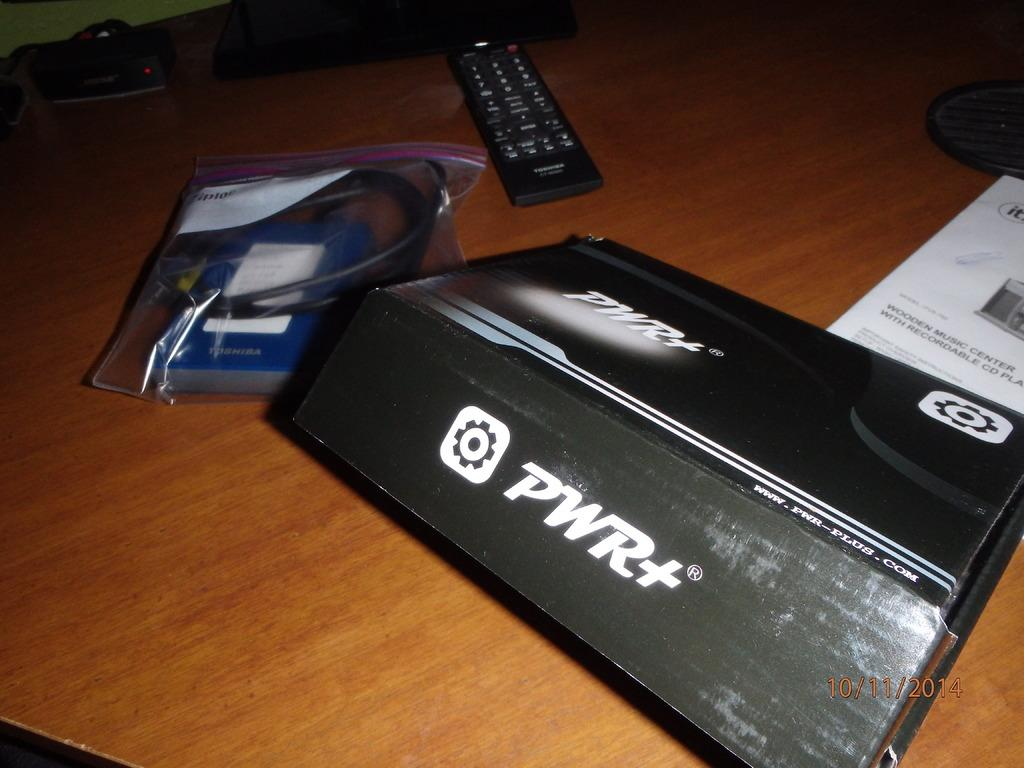<image>
Write a terse but informative summary of the picture. A black box with PWR+ on it  sits on a table along with a black remote control, instructions and a bag with a power pack in it. 